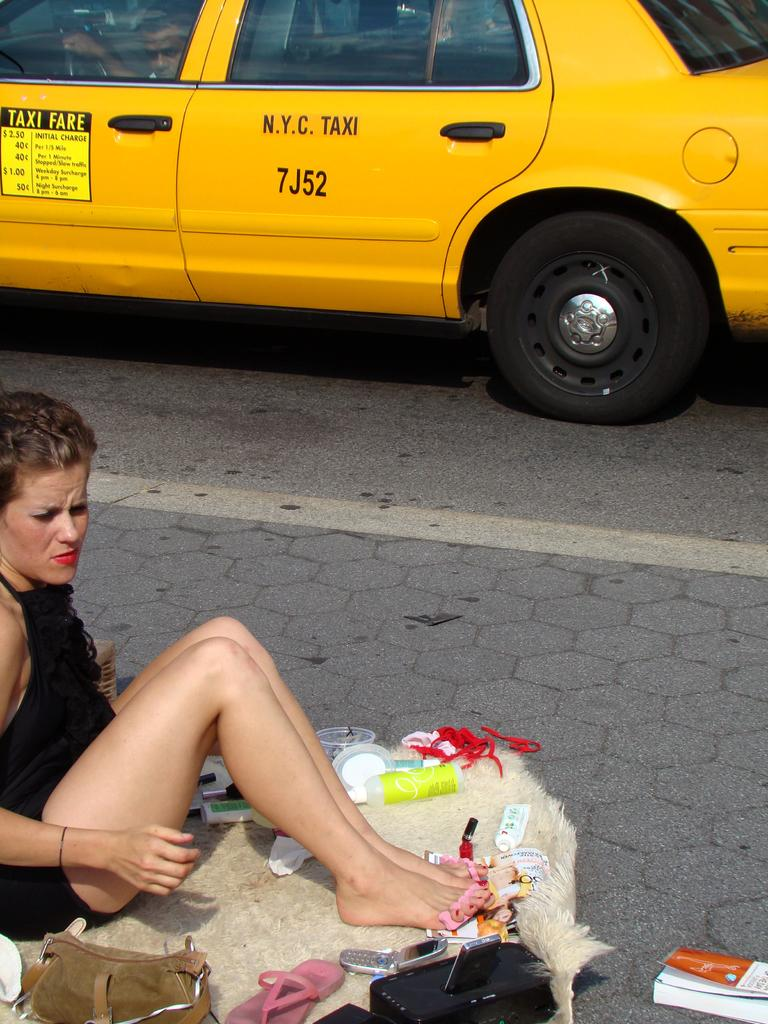<image>
Render a clear and concise summary of the photo. A woman sits on the sidewalk in front of a N.Y.C Taxi. 